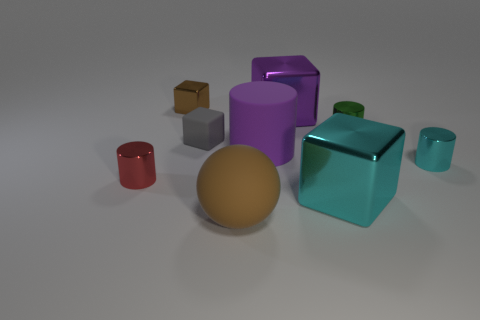Is the size of the brown cube the same as the cylinder that is left of the tiny brown object?
Ensure brevity in your answer.  Yes. What is the shape of the red thing?
Offer a very short reply. Cylinder. How many rubber cubes are the same color as the matte cylinder?
Offer a terse response. 0. There is another small object that is the same shape as the brown shiny object; what is its color?
Your answer should be compact. Gray. What number of shiny blocks are left of the metallic block on the left side of the large ball?
Your answer should be compact. 0. How many cubes are either brown matte objects or gray shiny objects?
Your answer should be very brief. 0. Are there any tiny red cylinders?
Keep it short and to the point. Yes. What is the size of the cyan metal object that is the same shape as the tiny gray matte object?
Ensure brevity in your answer.  Large. There is a large matte object that is to the left of the large purple cylinder that is to the left of the green metal cylinder; what is its shape?
Keep it short and to the point. Sphere. What number of cyan objects are either large matte cubes or rubber spheres?
Your answer should be very brief. 0. 